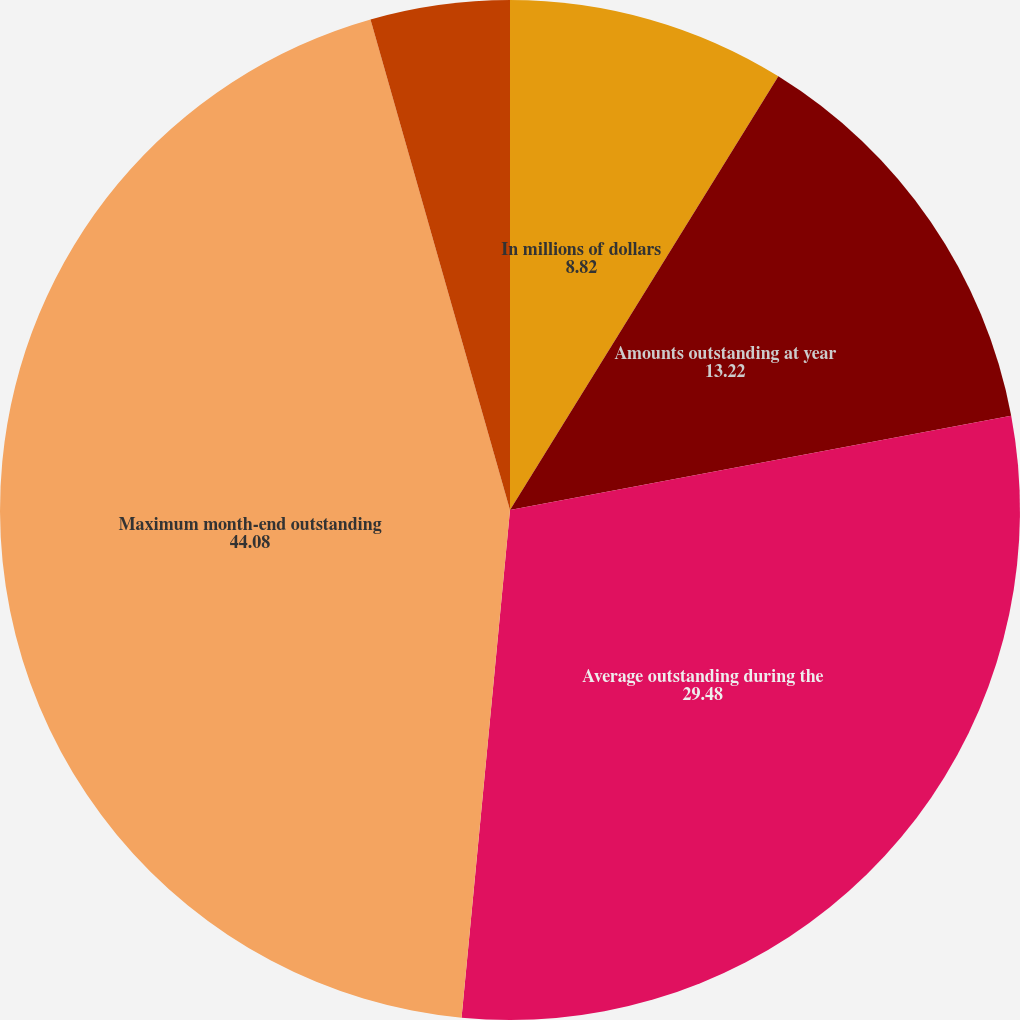Convert chart. <chart><loc_0><loc_0><loc_500><loc_500><pie_chart><fcel>In millions of dollars<fcel>Amounts outstanding at year<fcel>Average outstanding during the<fcel>Maximum month-end outstanding<fcel>During the year (3) (4)<fcel>At year end (5)<nl><fcel>8.82%<fcel>13.22%<fcel>29.48%<fcel>44.08%<fcel>4.41%<fcel>0.0%<nl></chart> 